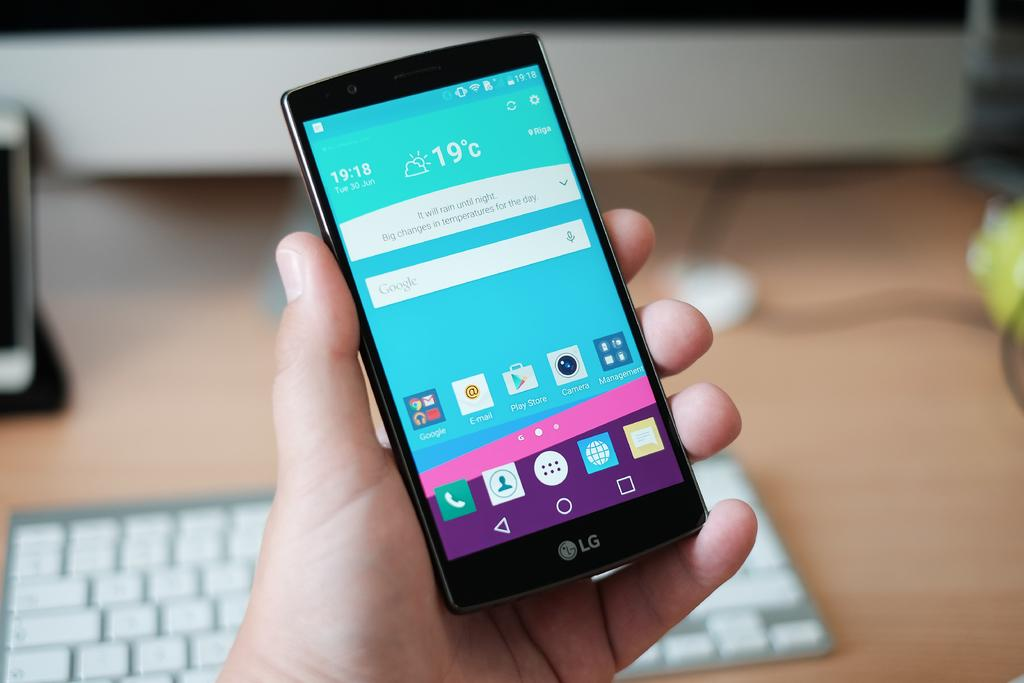<image>
Describe the image concisely. A hand holding a black phone with the weather pulled up and a keyboard is also beneath the hand. 